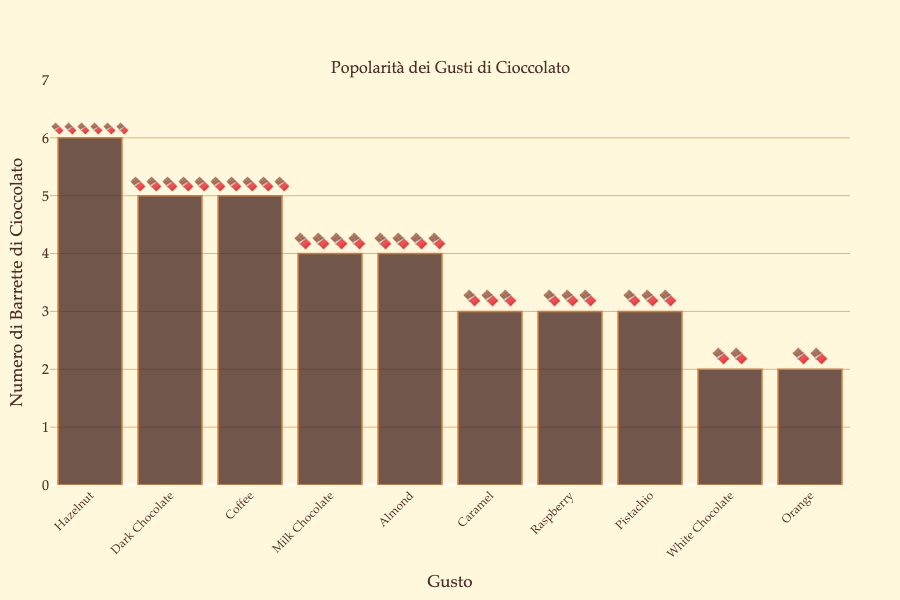Which chocolate flavor has the highest popularity based on the emoji representation? The flavor with the most chocolate bar emojis is the most popular. Counting the chocolate bar emojis for each flavor, we see that Hazelnut has the highest with six bars.
Answer: Hazelnut What is the total number of chocolate bar emojis present in the plot? To find the total number of chocolate bar emojis, I add up the counts of each flavor: 5 (Dark Chocolate) + 4 (Milk Chocolate) + 6 (Hazelnut) + 3 (Caramel) + 2 (White Chocolate) + 3 (Raspberry) + 5 (Coffee) + 3 (Pistachio) + 4 (Almond) + 2 (Orange) = 37.
Answer: 37 Which two flavors have an equal number of chocolate bar emojis representing their popularity? I look for pairs of flavors that have the same number of emojis. Dark Chocolate and Coffee both have 5 bar emojis. Additionally, Caramel and Pistachio both have 3 bar emojis, and White Chocolate and Orange both have 2 bar emojis.
Answer: Dark Chocolate and Coffee; Caramel and Pistachio; White Chocolate and Orange Which flavor is more popular, Almond or Raspberry? Comparing the emoji counts for each flavor, Almond has 4 emojis and Raspberry has 3 emojis. Thus, Almond is more popular.
Answer: Almond What is the difference in popularity (number of chocolate bar emojis) between the most and least popular flavors? The most popular flavor, Hazelnut, has 6 emojis. The least popular, tied between White Chocolate and Orange, has 2 emojis. The difference is 6 - 2.
Answer: 4 Describe the background and font colors used in the plot. The plot has a very light beige background. The font color is a dark brown, which matches the overall chocolate theme.
Answer: Light beige background, dark brown font Which flavors have exactly 4 chocolate bar emojis? By counting the emojis for each flavor, I see that Milk Chocolate and Almond each have 4 emojis.
Answer: Milk Chocolate, Almond What is the median popularity value in terms of chocolate bar emojis? To find the median, I list the counts in order: 2, 2, 3, 3, 3, 4, 4, 5, 5, 6. The median is the average of the middle two values, which are 3 and 4. (3+4)/2 = 3.5.
Answer: 3.5 